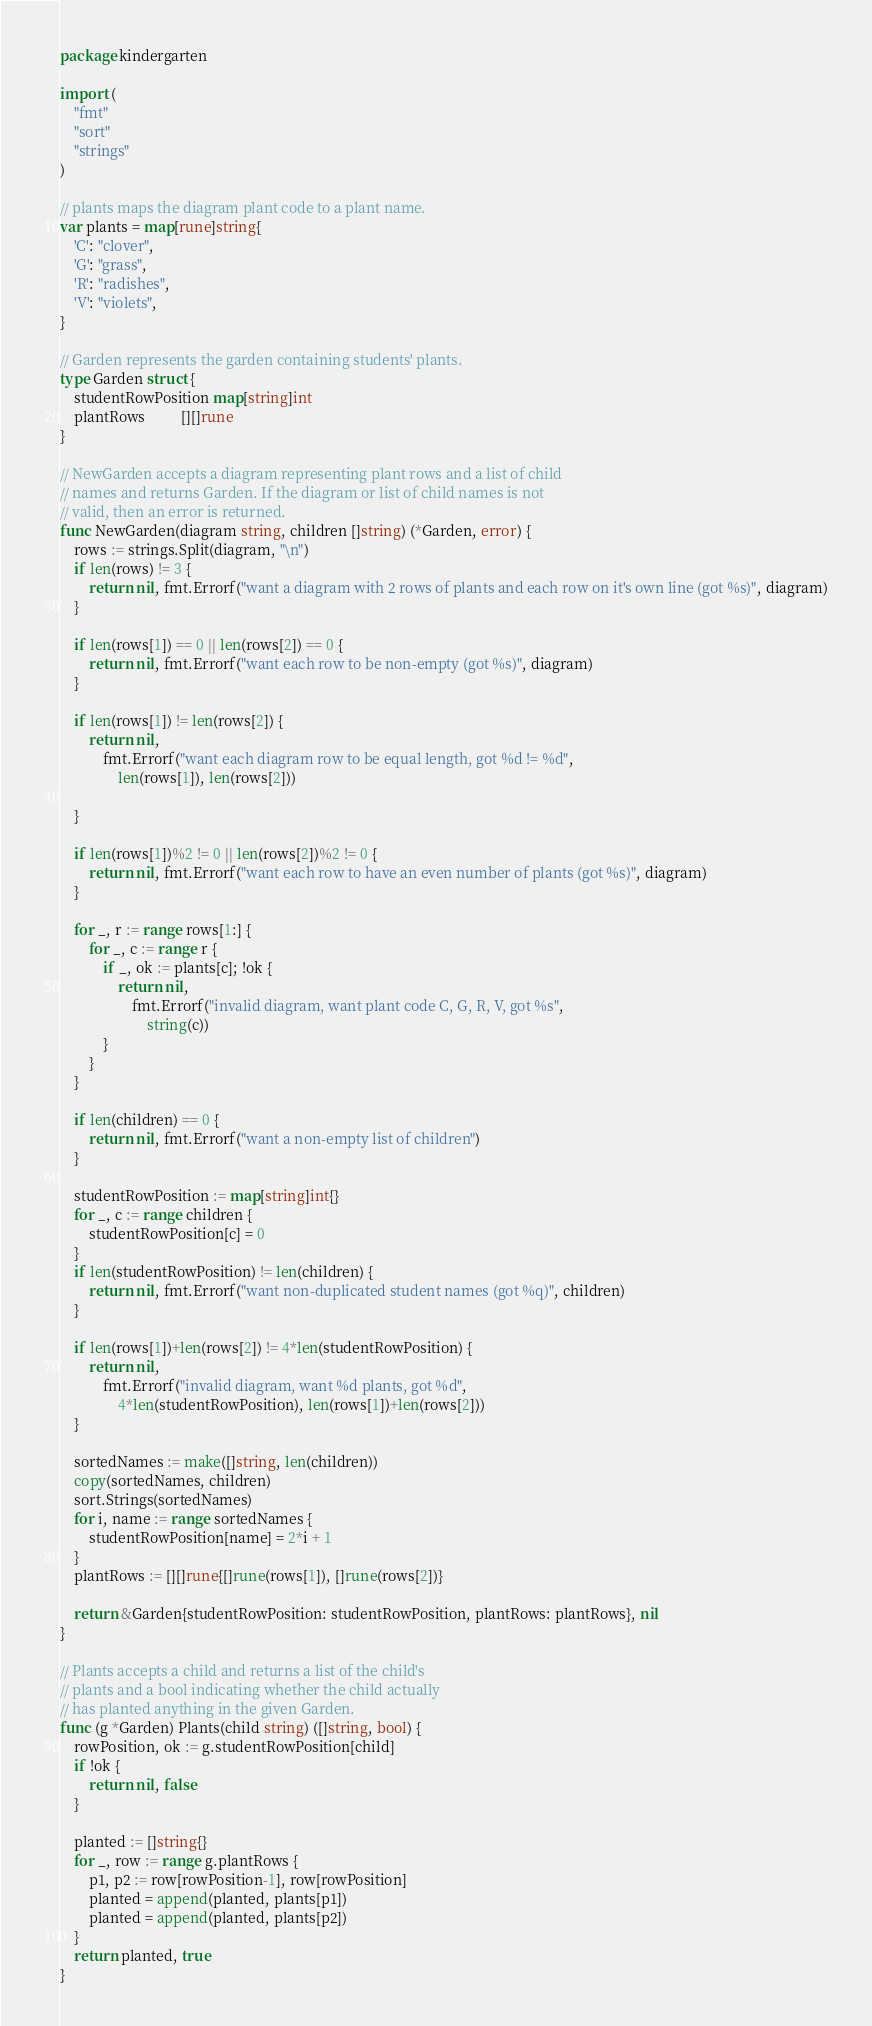<code> <loc_0><loc_0><loc_500><loc_500><_Go_>package kindergarten

import (
	"fmt"
	"sort"
	"strings"
)

// plants maps the diagram plant code to a plant name.
var plants = map[rune]string{
	'C': "clover",
	'G': "grass",
	'R': "radishes",
	'V': "violets",
}

// Garden represents the garden containing students' plants.
type Garden struct {
	studentRowPosition map[string]int
	plantRows          [][]rune
}

// NewGarden accepts a diagram representing plant rows and a list of child
// names and returns Garden. If the diagram or list of child names is not
// valid, then an error is returned.
func NewGarden(diagram string, children []string) (*Garden, error) {
	rows := strings.Split(diagram, "\n")
	if len(rows) != 3 {
		return nil, fmt.Errorf("want a diagram with 2 rows of plants and each row on it's own line (got %s)", diagram)
	}

	if len(rows[1]) == 0 || len(rows[2]) == 0 {
		return nil, fmt.Errorf("want each row to be non-empty (got %s)", diagram)
	}

	if len(rows[1]) != len(rows[2]) {
		return nil,
			fmt.Errorf("want each diagram row to be equal length, got %d != %d",
				len(rows[1]), len(rows[2]))

	}

	if len(rows[1])%2 != 0 || len(rows[2])%2 != 0 {
		return nil, fmt.Errorf("want each row to have an even number of plants (got %s)", diagram)
	}

	for _, r := range rows[1:] {
		for _, c := range r {
			if _, ok := plants[c]; !ok {
				return nil,
					fmt.Errorf("invalid diagram, want plant code C, G, R, V, got %s",
						string(c))
			}
		}
	}

	if len(children) == 0 {
		return nil, fmt.Errorf("want a non-empty list of children")
	}

	studentRowPosition := map[string]int{}
	for _, c := range children {
		studentRowPosition[c] = 0
	}
	if len(studentRowPosition) != len(children) {
		return nil, fmt.Errorf("want non-duplicated student names (got %q)", children)
	}

	if len(rows[1])+len(rows[2]) != 4*len(studentRowPosition) {
		return nil,
			fmt.Errorf("invalid diagram, want %d plants, got %d",
				4*len(studentRowPosition), len(rows[1])+len(rows[2]))
	}

	sortedNames := make([]string, len(children))
	copy(sortedNames, children)
	sort.Strings(sortedNames)
	for i, name := range sortedNames {
		studentRowPosition[name] = 2*i + 1
	}
	plantRows := [][]rune{[]rune(rows[1]), []rune(rows[2])}

	return &Garden{studentRowPosition: studentRowPosition, plantRows: plantRows}, nil
}

// Plants accepts a child and returns a list of the child's
// plants and a bool indicating whether the child actually
// has planted anything in the given Garden.
func (g *Garden) Plants(child string) ([]string, bool) {
	rowPosition, ok := g.studentRowPosition[child]
	if !ok {
		return nil, false
	}

	planted := []string{}
	for _, row := range g.plantRows {
		p1, p2 := row[rowPosition-1], row[rowPosition]
		planted = append(planted, plants[p1])
		planted = append(planted, plants[p2])
	}
	return planted, true
}
</code> 